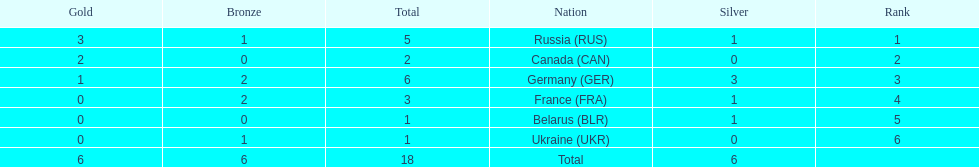Which country won more total medals than tue french, but less than the germans in the 1994 winter olympic biathlon? Russia. 